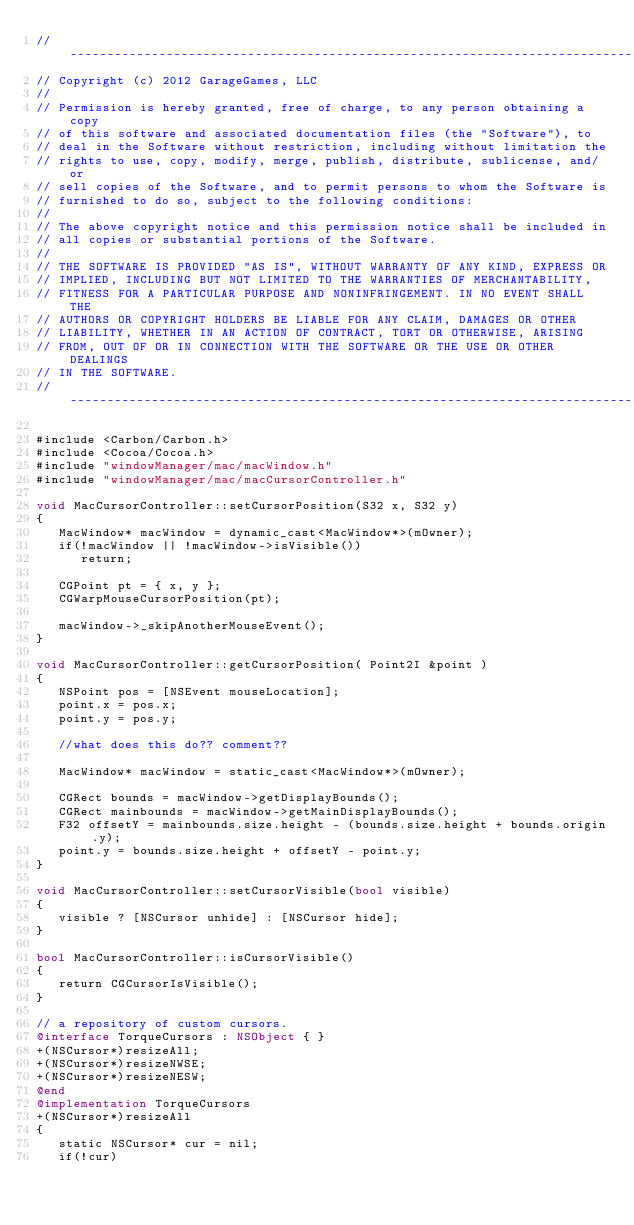<code> <loc_0><loc_0><loc_500><loc_500><_ObjectiveC_>//-----------------------------------------------------------------------------
// Copyright (c) 2012 GarageGames, LLC
//
// Permission is hereby granted, free of charge, to any person obtaining a copy
// of this software and associated documentation files (the "Software"), to
// deal in the Software without restriction, including without limitation the
// rights to use, copy, modify, merge, publish, distribute, sublicense, and/or
// sell copies of the Software, and to permit persons to whom the Software is
// furnished to do so, subject to the following conditions:
//
// The above copyright notice and this permission notice shall be included in
// all copies or substantial portions of the Software.
//
// THE SOFTWARE IS PROVIDED "AS IS", WITHOUT WARRANTY OF ANY KIND, EXPRESS OR
// IMPLIED, INCLUDING BUT NOT LIMITED TO THE WARRANTIES OF MERCHANTABILITY,
// FITNESS FOR A PARTICULAR PURPOSE AND NONINFRINGEMENT. IN NO EVENT SHALL THE
// AUTHORS OR COPYRIGHT HOLDERS BE LIABLE FOR ANY CLAIM, DAMAGES OR OTHER
// LIABILITY, WHETHER IN AN ACTION OF CONTRACT, TORT OR OTHERWISE, ARISING
// FROM, OUT OF OR IN CONNECTION WITH THE SOFTWARE OR THE USE OR OTHER DEALINGS
// IN THE SOFTWARE.
//-----------------------------------------------------------------------------

#include <Carbon/Carbon.h>
#include <Cocoa/Cocoa.h>
#include "windowManager/mac/macWindow.h"
#include "windowManager/mac/macCursorController.h"

void MacCursorController::setCursorPosition(S32 x, S32 y)
{
   MacWindow* macWindow = dynamic_cast<MacWindow*>(mOwner);
   if(!macWindow || !macWindow->isVisible())
      return;
      
   CGPoint pt = { x, y };
   CGWarpMouseCursorPosition(pt);
   
   macWindow->_skipAnotherMouseEvent();
}

void MacCursorController::getCursorPosition( Point2I &point )
{
   NSPoint pos = [NSEvent mouseLocation];
   point.x = pos.x;
   point.y = pos.y;
   
   //what does this do?? comment??
   
   MacWindow* macWindow = static_cast<MacWindow*>(mOwner);
   
   CGRect bounds = macWindow->getDisplayBounds();
   CGRect mainbounds = macWindow->getMainDisplayBounds();
   F32 offsetY = mainbounds.size.height - (bounds.size.height + bounds.origin.y);
   point.y = bounds.size.height + offsetY - point.y;
}

void MacCursorController::setCursorVisible(bool visible)
{
   visible ? [NSCursor unhide] : [NSCursor hide];
}

bool MacCursorController::isCursorVisible()
{
   return CGCursorIsVisible();
}

// a repository of custom cursors.
@interface TorqueCursors : NSObject { }
+(NSCursor*)resizeAll;
+(NSCursor*)resizeNWSE;
+(NSCursor*)resizeNESW;
@end
@implementation TorqueCursors
+(NSCursor*)resizeAll
{
   static NSCursor* cur = nil;
   if(!cur)</code> 